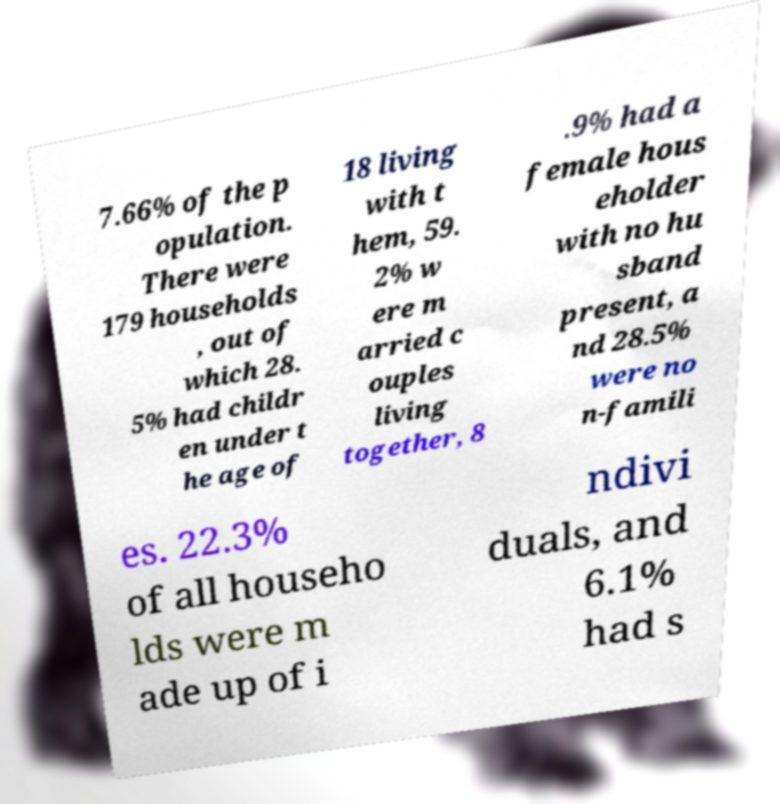Could you assist in decoding the text presented in this image and type it out clearly? 7.66% of the p opulation. There were 179 households , out of which 28. 5% had childr en under t he age of 18 living with t hem, 59. 2% w ere m arried c ouples living together, 8 .9% had a female hous eholder with no hu sband present, a nd 28.5% were no n-famili es. 22.3% of all househo lds were m ade up of i ndivi duals, and 6.1% had s 